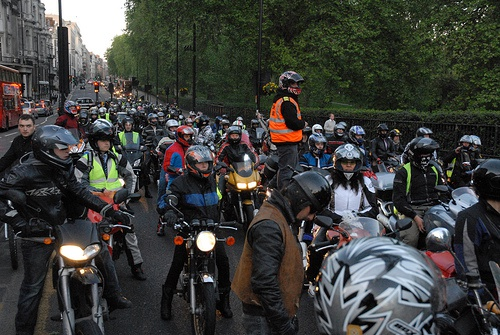Describe the objects in this image and their specific colors. I can see people in gray, black, and darkblue tones, people in gray, black, and maroon tones, motorcycle in gray, black, and darkgray tones, people in gray, black, darkgray, and navy tones, and people in gray, black, blue, and navy tones in this image. 